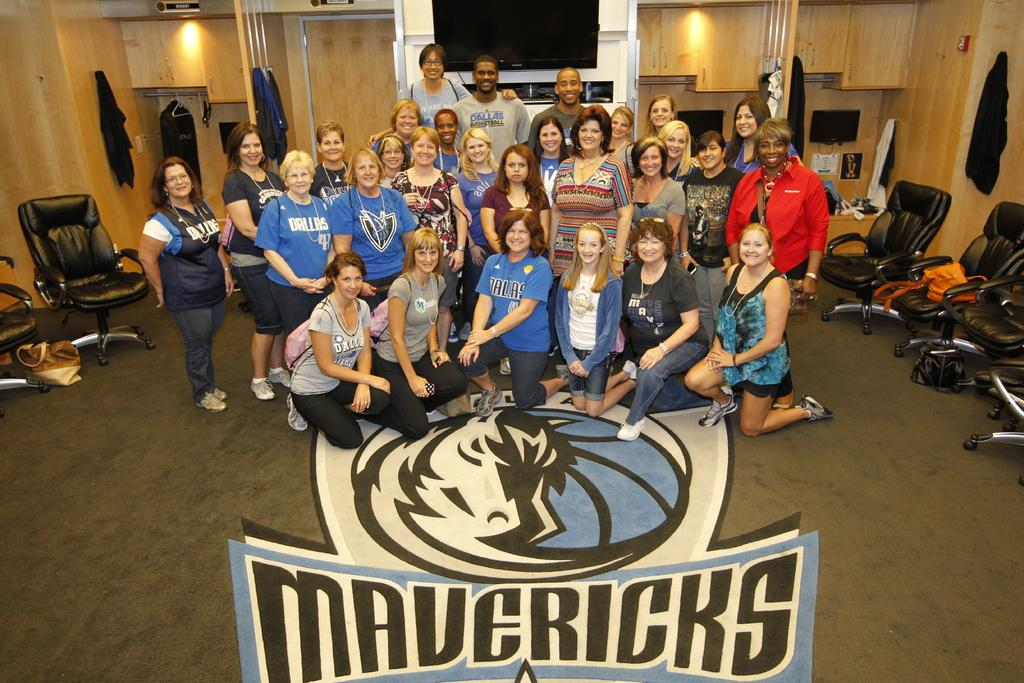How many people are in the room in the image? There is a group of people in the room. What type of furniture is in the room? There is a chair in the room. What is on the floor in the room? There is a bag on the floor. What can be seen in the background of the room? There is a television, a light, and a rack on a wooden wall in the background. What type of tooth is visible in the image? There is no tooth present in the image. What meal are the people in the room eating? The image does not show any meal being eaten, so it cannot be determined from the image. 